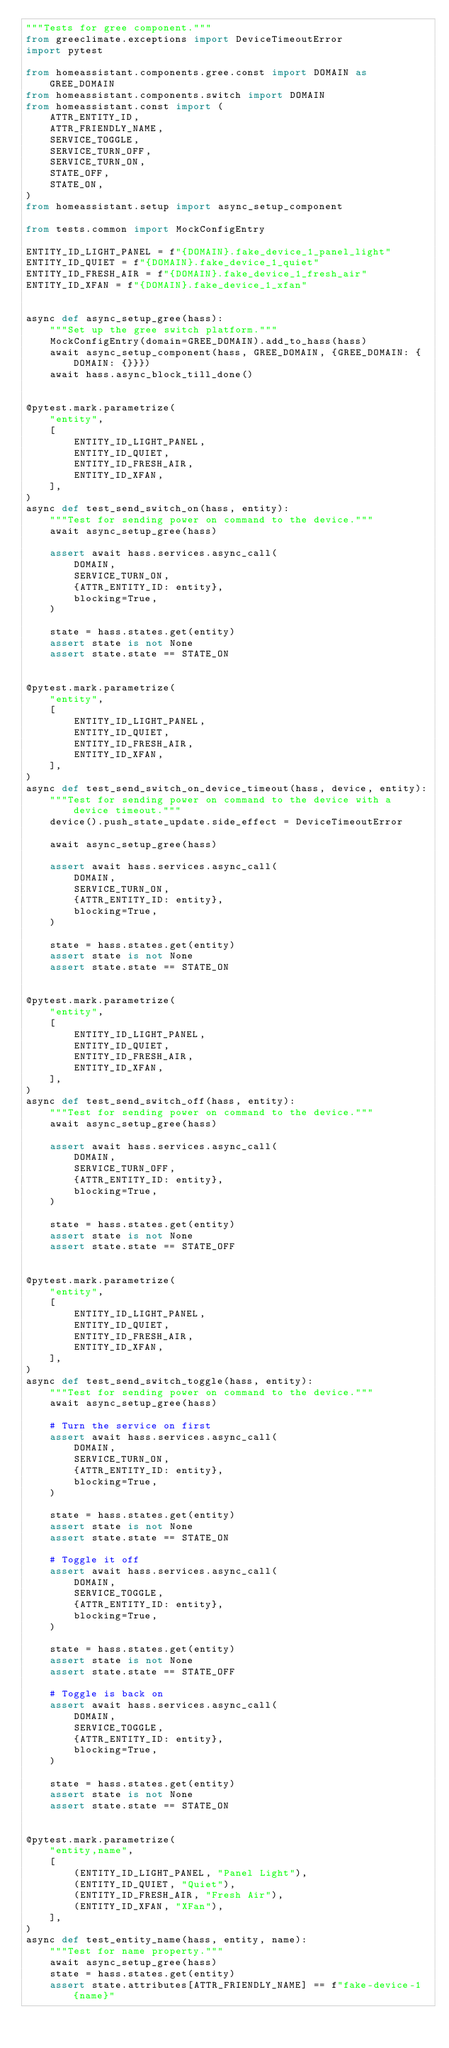<code> <loc_0><loc_0><loc_500><loc_500><_Python_>"""Tests for gree component."""
from greeclimate.exceptions import DeviceTimeoutError
import pytest

from homeassistant.components.gree.const import DOMAIN as GREE_DOMAIN
from homeassistant.components.switch import DOMAIN
from homeassistant.const import (
    ATTR_ENTITY_ID,
    ATTR_FRIENDLY_NAME,
    SERVICE_TOGGLE,
    SERVICE_TURN_OFF,
    SERVICE_TURN_ON,
    STATE_OFF,
    STATE_ON,
)
from homeassistant.setup import async_setup_component

from tests.common import MockConfigEntry

ENTITY_ID_LIGHT_PANEL = f"{DOMAIN}.fake_device_1_panel_light"
ENTITY_ID_QUIET = f"{DOMAIN}.fake_device_1_quiet"
ENTITY_ID_FRESH_AIR = f"{DOMAIN}.fake_device_1_fresh_air"
ENTITY_ID_XFAN = f"{DOMAIN}.fake_device_1_xfan"


async def async_setup_gree(hass):
    """Set up the gree switch platform."""
    MockConfigEntry(domain=GREE_DOMAIN).add_to_hass(hass)
    await async_setup_component(hass, GREE_DOMAIN, {GREE_DOMAIN: {DOMAIN: {}}})
    await hass.async_block_till_done()


@pytest.mark.parametrize(
    "entity",
    [
        ENTITY_ID_LIGHT_PANEL,
        ENTITY_ID_QUIET,
        ENTITY_ID_FRESH_AIR,
        ENTITY_ID_XFAN,
    ],
)
async def test_send_switch_on(hass, entity):
    """Test for sending power on command to the device."""
    await async_setup_gree(hass)

    assert await hass.services.async_call(
        DOMAIN,
        SERVICE_TURN_ON,
        {ATTR_ENTITY_ID: entity},
        blocking=True,
    )

    state = hass.states.get(entity)
    assert state is not None
    assert state.state == STATE_ON


@pytest.mark.parametrize(
    "entity",
    [
        ENTITY_ID_LIGHT_PANEL,
        ENTITY_ID_QUIET,
        ENTITY_ID_FRESH_AIR,
        ENTITY_ID_XFAN,
    ],
)
async def test_send_switch_on_device_timeout(hass, device, entity):
    """Test for sending power on command to the device with a device timeout."""
    device().push_state_update.side_effect = DeviceTimeoutError

    await async_setup_gree(hass)

    assert await hass.services.async_call(
        DOMAIN,
        SERVICE_TURN_ON,
        {ATTR_ENTITY_ID: entity},
        blocking=True,
    )

    state = hass.states.get(entity)
    assert state is not None
    assert state.state == STATE_ON


@pytest.mark.parametrize(
    "entity",
    [
        ENTITY_ID_LIGHT_PANEL,
        ENTITY_ID_QUIET,
        ENTITY_ID_FRESH_AIR,
        ENTITY_ID_XFAN,
    ],
)
async def test_send_switch_off(hass, entity):
    """Test for sending power on command to the device."""
    await async_setup_gree(hass)

    assert await hass.services.async_call(
        DOMAIN,
        SERVICE_TURN_OFF,
        {ATTR_ENTITY_ID: entity},
        blocking=True,
    )

    state = hass.states.get(entity)
    assert state is not None
    assert state.state == STATE_OFF


@pytest.mark.parametrize(
    "entity",
    [
        ENTITY_ID_LIGHT_PANEL,
        ENTITY_ID_QUIET,
        ENTITY_ID_FRESH_AIR,
        ENTITY_ID_XFAN,
    ],
)
async def test_send_switch_toggle(hass, entity):
    """Test for sending power on command to the device."""
    await async_setup_gree(hass)

    # Turn the service on first
    assert await hass.services.async_call(
        DOMAIN,
        SERVICE_TURN_ON,
        {ATTR_ENTITY_ID: entity},
        blocking=True,
    )

    state = hass.states.get(entity)
    assert state is not None
    assert state.state == STATE_ON

    # Toggle it off
    assert await hass.services.async_call(
        DOMAIN,
        SERVICE_TOGGLE,
        {ATTR_ENTITY_ID: entity},
        blocking=True,
    )

    state = hass.states.get(entity)
    assert state is not None
    assert state.state == STATE_OFF

    # Toggle is back on
    assert await hass.services.async_call(
        DOMAIN,
        SERVICE_TOGGLE,
        {ATTR_ENTITY_ID: entity},
        blocking=True,
    )

    state = hass.states.get(entity)
    assert state is not None
    assert state.state == STATE_ON


@pytest.mark.parametrize(
    "entity,name",
    [
        (ENTITY_ID_LIGHT_PANEL, "Panel Light"),
        (ENTITY_ID_QUIET, "Quiet"),
        (ENTITY_ID_FRESH_AIR, "Fresh Air"),
        (ENTITY_ID_XFAN, "XFan"),
    ],
)
async def test_entity_name(hass, entity, name):
    """Test for name property."""
    await async_setup_gree(hass)
    state = hass.states.get(entity)
    assert state.attributes[ATTR_FRIENDLY_NAME] == f"fake-device-1 {name}"
</code> 